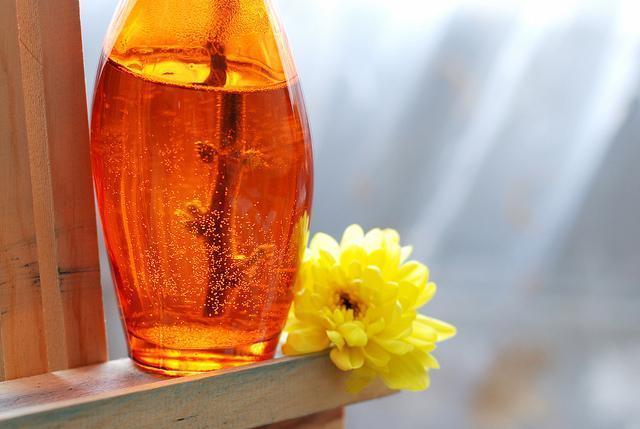How many tracks have no trains on them?
Give a very brief answer. 0. 